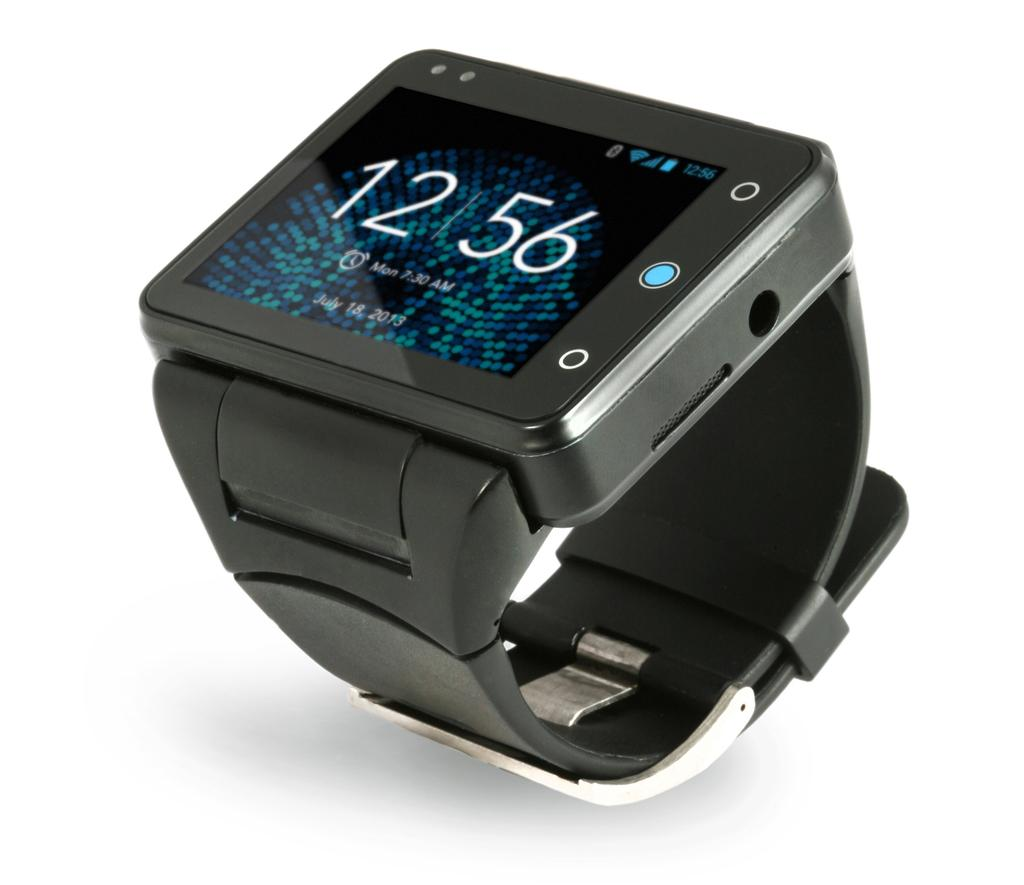What object is the main focus of the image? There is a watch in the image. What feature is present on the watch? The watch has numbers. What can be seen on the screen of the watch? There is text and symbols on the screen of the watch. What color is the background of the watch? The background of the watch is white. What type of boot is being worn by the person in the image? There is no person or boot present in the image; it only features a watch. What kind of art is displayed on the wall behind the watch? There is no art or wall visible in the image; it only shows a watch with a white background. 